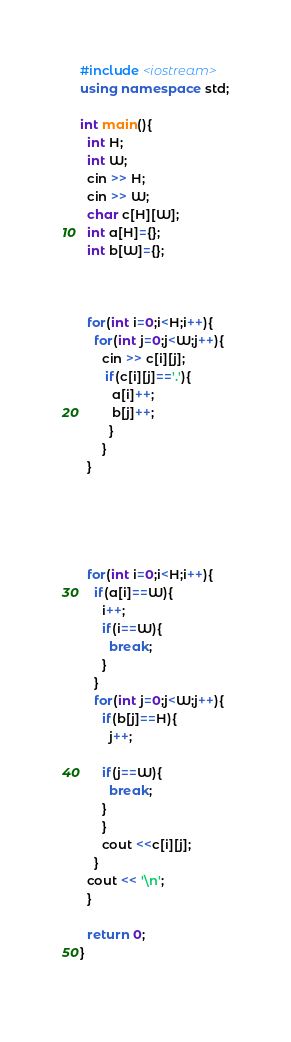Convert code to text. <code><loc_0><loc_0><loc_500><loc_500><_C++_>#include <iostream>
using namespace std;

int main(){
  int H;
  int W;
  cin >> H;
  cin >> W;
  char c[H][W];
  int a[H]={};
  int b[W]={};

  
  
  for(int i=0;i<H;i++){
    for(int j=0;j<W;j++){
      cin >> c[i][j];
       if(c[i][j]=='.'){
         a[i]++;
         b[j]++;
        }
      }
  }





  for(int i=0;i<H;i++){
    if(a[i]==W){
      i++;
      if(i==W){
        break;
      }
    }
    for(int j=0;j<W;j++){
      if(b[j]==H){
        j++;
      
      if(j==W){
        break;
      }
      }
      cout <<c[i][j];
    }
  cout << '\n';
  }
  
  return 0;
}
   
</code> 